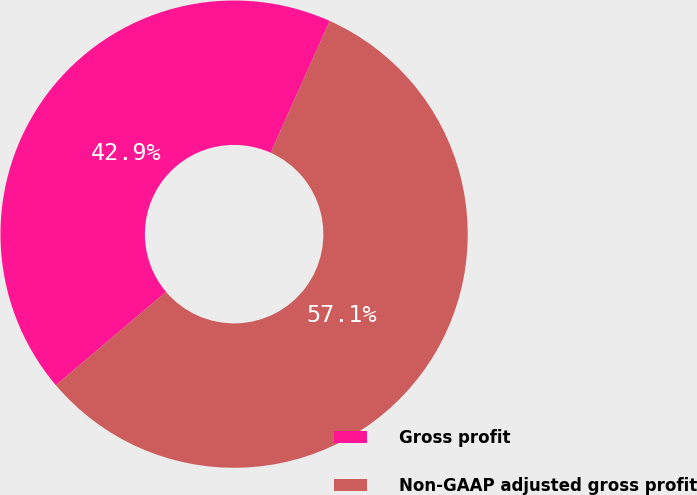Convert chart. <chart><loc_0><loc_0><loc_500><loc_500><pie_chart><fcel>Gross profit<fcel>Non-GAAP adjusted gross profit<nl><fcel>42.91%<fcel>57.09%<nl></chart> 